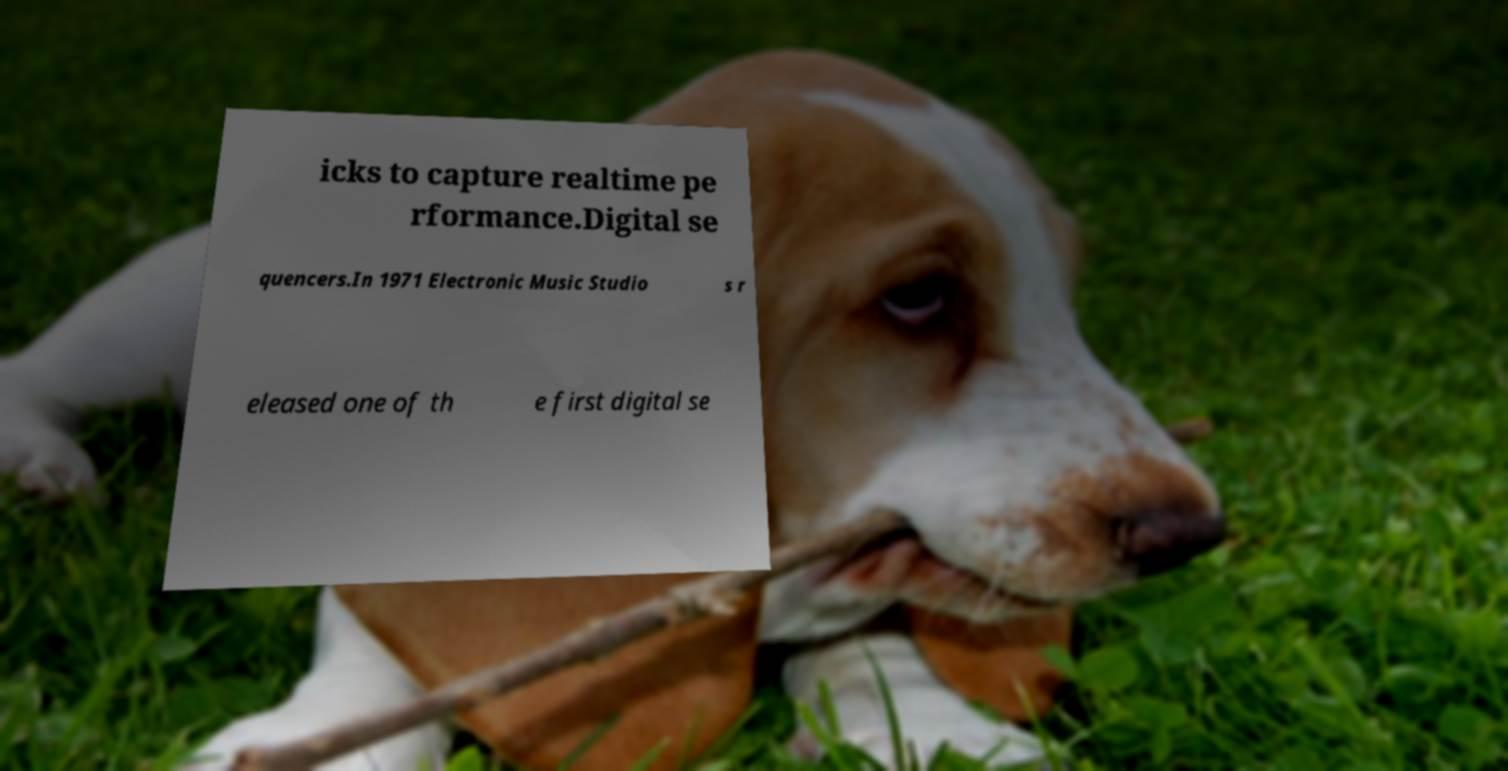Please read and relay the text visible in this image. What does it say? icks to capture realtime pe rformance.Digital se quencers.In 1971 Electronic Music Studio s r eleased one of th e first digital se 